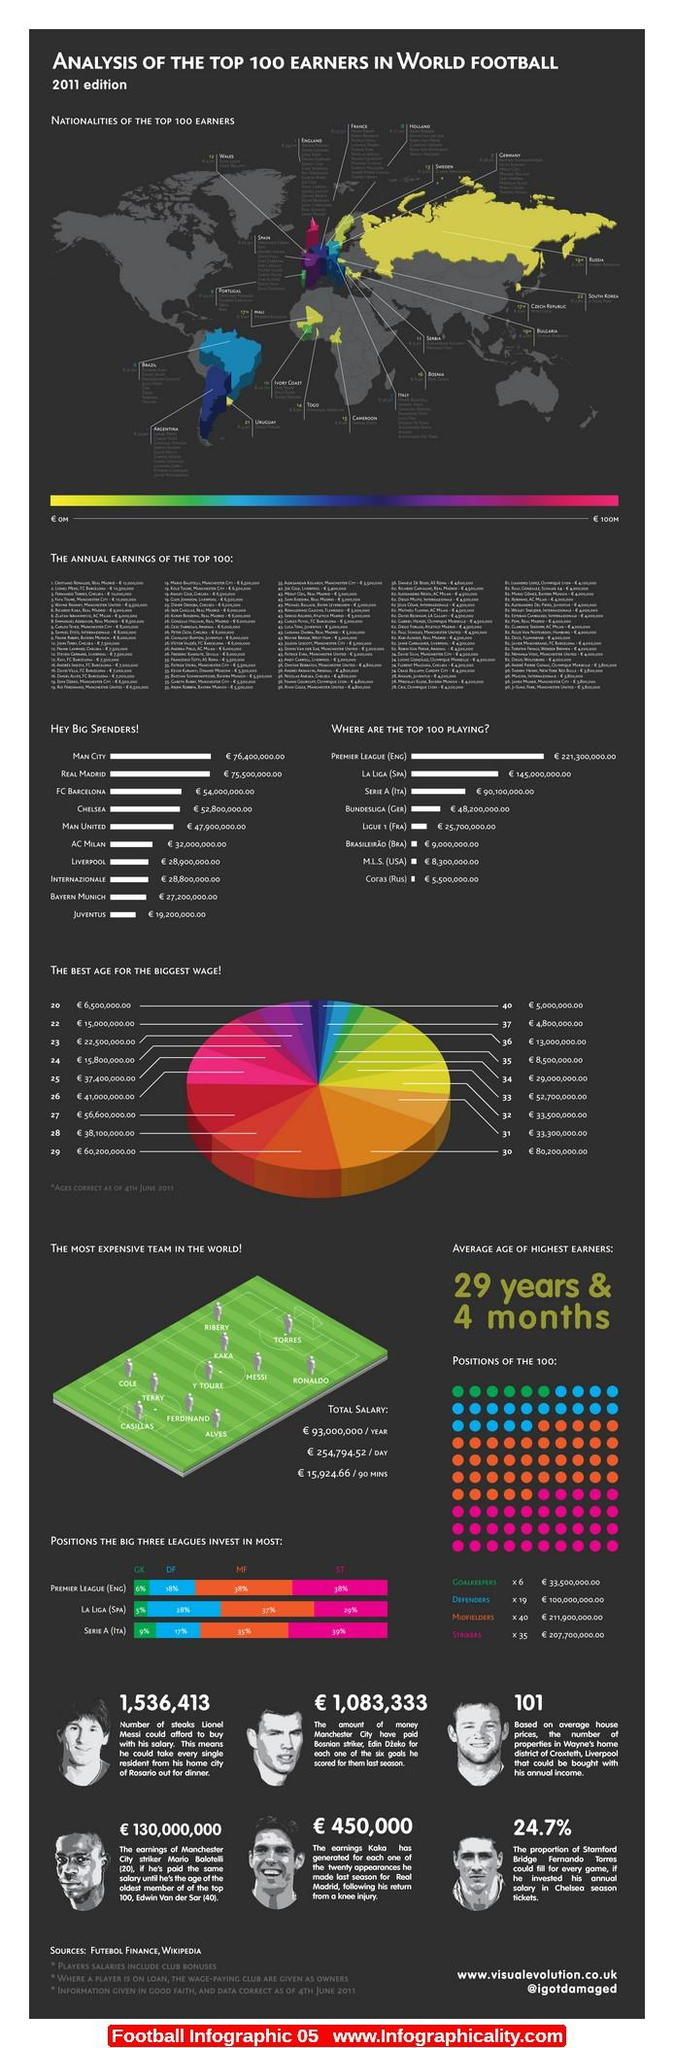Outline some significant characteristics in this image. Juventus, who is known for being a major spender in the football world, is actually the team that spends the least among the top spenders. The big three leagues invest the least in goalkeepers, with their position being the least valued. Chelsea is the fourth best big spender. Manchester United is the fifth best big spender. According to statistics, the Premier League (England) invests a significant percentage of its budget on midfielders, with a specific focus on this position. Specifically, it is estimated that midfielders receive 38% of the league's investment in player transfers. 